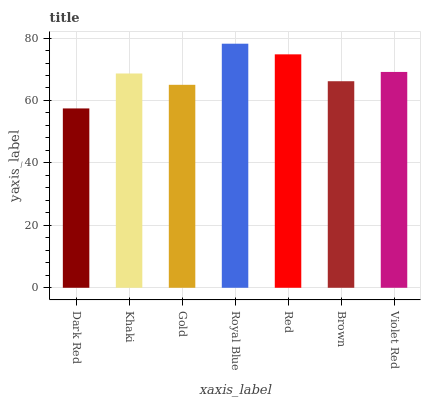Is Dark Red the minimum?
Answer yes or no. Yes. Is Royal Blue the maximum?
Answer yes or no. Yes. Is Khaki the minimum?
Answer yes or no. No. Is Khaki the maximum?
Answer yes or no. No. Is Khaki greater than Dark Red?
Answer yes or no. Yes. Is Dark Red less than Khaki?
Answer yes or no. Yes. Is Dark Red greater than Khaki?
Answer yes or no. No. Is Khaki less than Dark Red?
Answer yes or no. No. Is Khaki the high median?
Answer yes or no. Yes. Is Khaki the low median?
Answer yes or no. Yes. Is Gold the high median?
Answer yes or no. No. Is Brown the low median?
Answer yes or no. No. 